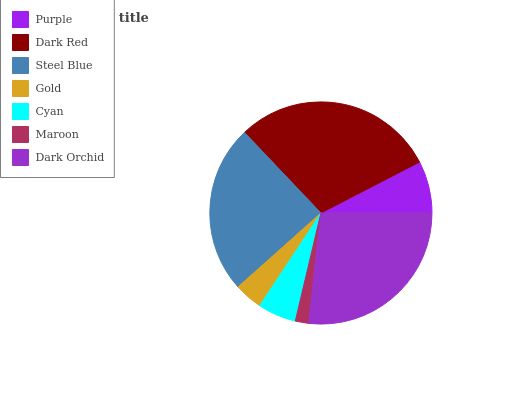Is Maroon the minimum?
Answer yes or no. Yes. Is Dark Red the maximum?
Answer yes or no. Yes. Is Steel Blue the minimum?
Answer yes or no. No. Is Steel Blue the maximum?
Answer yes or no. No. Is Dark Red greater than Steel Blue?
Answer yes or no. Yes. Is Steel Blue less than Dark Red?
Answer yes or no. Yes. Is Steel Blue greater than Dark Red?
Answer yes or no. No. Is Dark Red less than Steel Blue?
Answer yes or no. No. Is Purple the high median?
Answer yes or no. Yes. Is Purple the low median?
Answer yes or no. Yes. Is Maroon the high median?
Answer yes or no. No. Is Dark Orchid the low median?
Answer yes or no. No. 